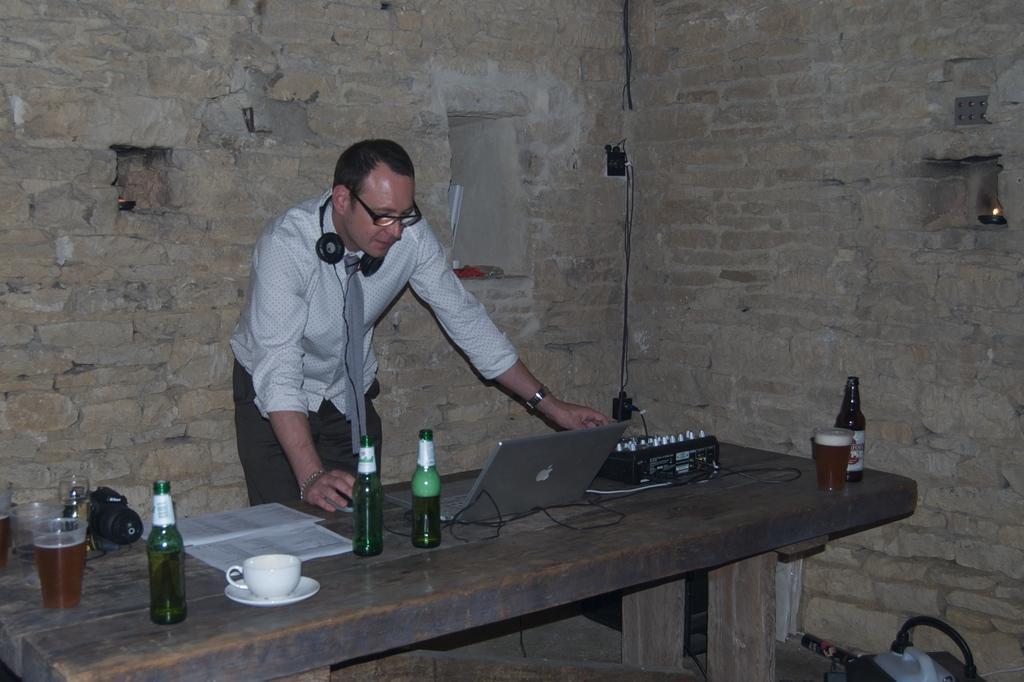Could you give a brief overview of what you see in this image? In this picture we can see man wore tie, headsets, spectacle and looking at laptop on table and we have bottles, cup, saucer, book, glass with drink in it, some device on same table and in background we can see wall. 